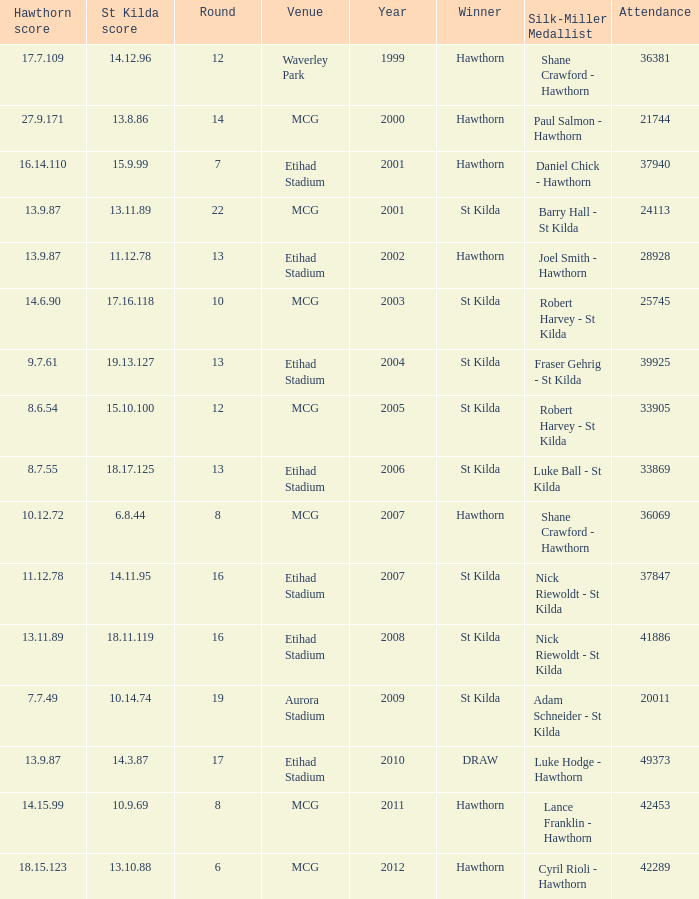Help me parse the entirety of this table. {'header': ['Hawthorn score', 'St Kilda score', 'Round', 'Venue', 'Year', 'Winner', 'Silk-Miller Medallist', 'Attendance'], 'rows': [['17.7.109', '14.12.96', '12', 'Waverley Park', '1999', 'Hawthorn', 'Shane Crawford - Hawthorn', '36381'], ['27.9.171', '13.8.86', '14', 'MCG', '2000', 'Hawthorn', 'Paul Salmon - Hawthorn', '21744'], ['16.14.110', '15.9.99', '7', 'Etihad Stadium', '2001', 'Hawthorn', 'Daniel Chick - Hawthorn', '37940'], ['13.9.87', '13.11.89', '22', 'MCG', '2001', 'St Kilda', 'Barry Hall - St Kilda', '24113'], ['13.9.87', '11.12.78', '13', 'Etihad Stadium', '2002', 'Hawthorn', 'Joel Smith - Hawthorn', '28928'], ['14.6.90', '17.16.118', '10', 'MCG', '2003', 'St Kilda', 'Robert Harvey - St Kilda', '25745'], ['9.7.61', '19.13.127', '13', 'Etihad Stadium', '2004', 'St Kilda', 'Fraser Gehrig - St Kilda', '39925'], ['8.6.54', '15.10.100', '12', 'MCG', '2005', 'St Kilda', 'Robert Harvey - St Kilda', '33905'], ['8.7.55', '18.17.125', '13', 'Etihad Stadium', '2006', 'St Kilda', 'Luke Ball - St Kilda', '33869'], ['10.12.72', '6.8.44', '8', 'MCG', '2007', 'Hawthorn', 'Shane Crawford - Hawthorn', '36069'], ['11.12.78', '14.11.95', '16', 'Etihad Stadium', '2007', 'St Kilda', 'Nick Riewoldt - St Kilda', '37847'], ['13.11.89', '18.11.119', '16', 'Etihad Stadium', '2008', 'St Kilda', 'Nick Riewoldt - St Kilda', '41886'], ['7.7.49', '10.14.74', '19', 'Aurora Stadium', '2009', 'St Kilda', 'Adam Schneider - St Kilda', '20011'], ['13.9.87', '14.3.87', '17', 'Etihad Stadium', '2010', 'DRAW', 'Luke Hodge - Hawthorn', '49373'], ['14.15.99', '10.9.69', '8', 'MCG', '2011', 'Hawthorn', 'Lance Franklin - Hawthorn', '42453'], ['18.15.123', '13.10.88', '6', 'MCG', '2012', 'Hawthorn', 'Cyril Rioli - Hawthorn', '42289']]} What the listed in round when the hawthorn score is 17.7.109? 12.0. 